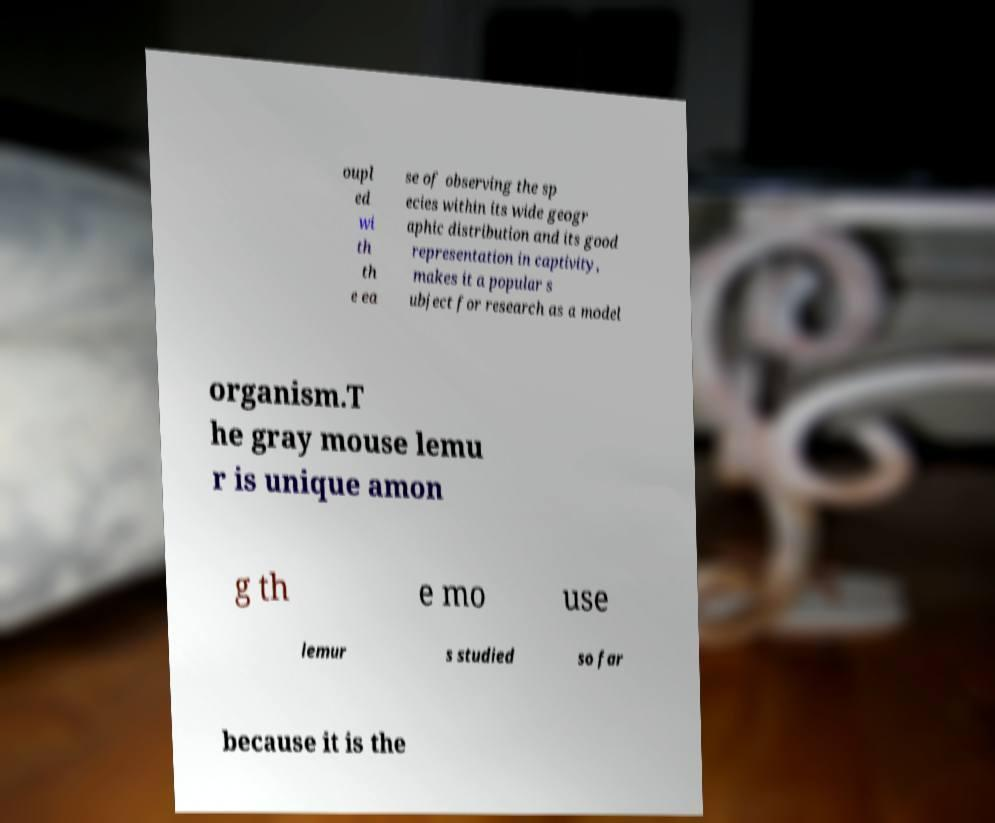Can you read and provide the text displayed in the image?This photo seems to have some interesting text. Can you extract and type it out for me? oupl ed wi th th e ea se of observing the sp ecies within its wide geogr aphic distribution and its good representation in captivity, makes it a popular s ubject for research as a model organism.T he gray mouse lemu r is unique amon g th e mo use lemur s studied so far because it is the 